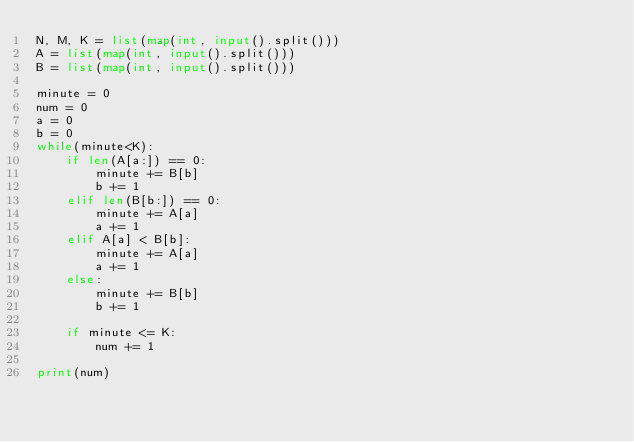<code> <loc_0><loc_0><loc_500><loc_500><_Python_>N, M, K = list(map(int, input().split()))
A = list(map(int, input().split()))
B = list(map(int, input().split()))

minute = 0
num = 0
a = 0
b = 0
while(minute<K):
    if len(A[a:]) == 0:
        minute += B[b]
        b += 1 
    elif len(B[b:]) == 0:
        minute += A[a]
        a += 1
    elif A[a] < B[b]:
        minute += A[a]
        a += 1
    else:
        minute += B[b]
        b += 1
    
    if minute <= K:
        num += 1

print(num)</code> 